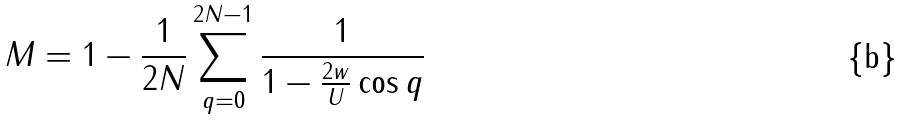<formula> <loc_0><loc_0><loc_500><loc_500>M = 1 - \frac { 1 } { 2 N } \sum _ { q = 0 } ^ { 2 N - 1 } \frac { 1 } { 1 - \frac { 2 w } { U } \cos q }</formula> 